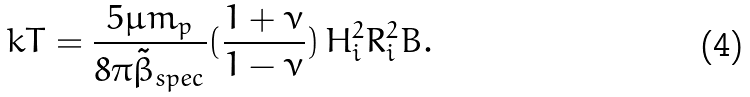<formula> <loc_0><loc_0><loc_500><loc_500>k T = \frac { 5 \mu m _ { p } } { 8 \pi \tilde { \beta } _ { s p e c } } ( \frac { 1 + \nu } { 1 - \nu } ) \, H _ { i } ^ { 2 } R _ { i } ^ { 2 } B .</formula> 